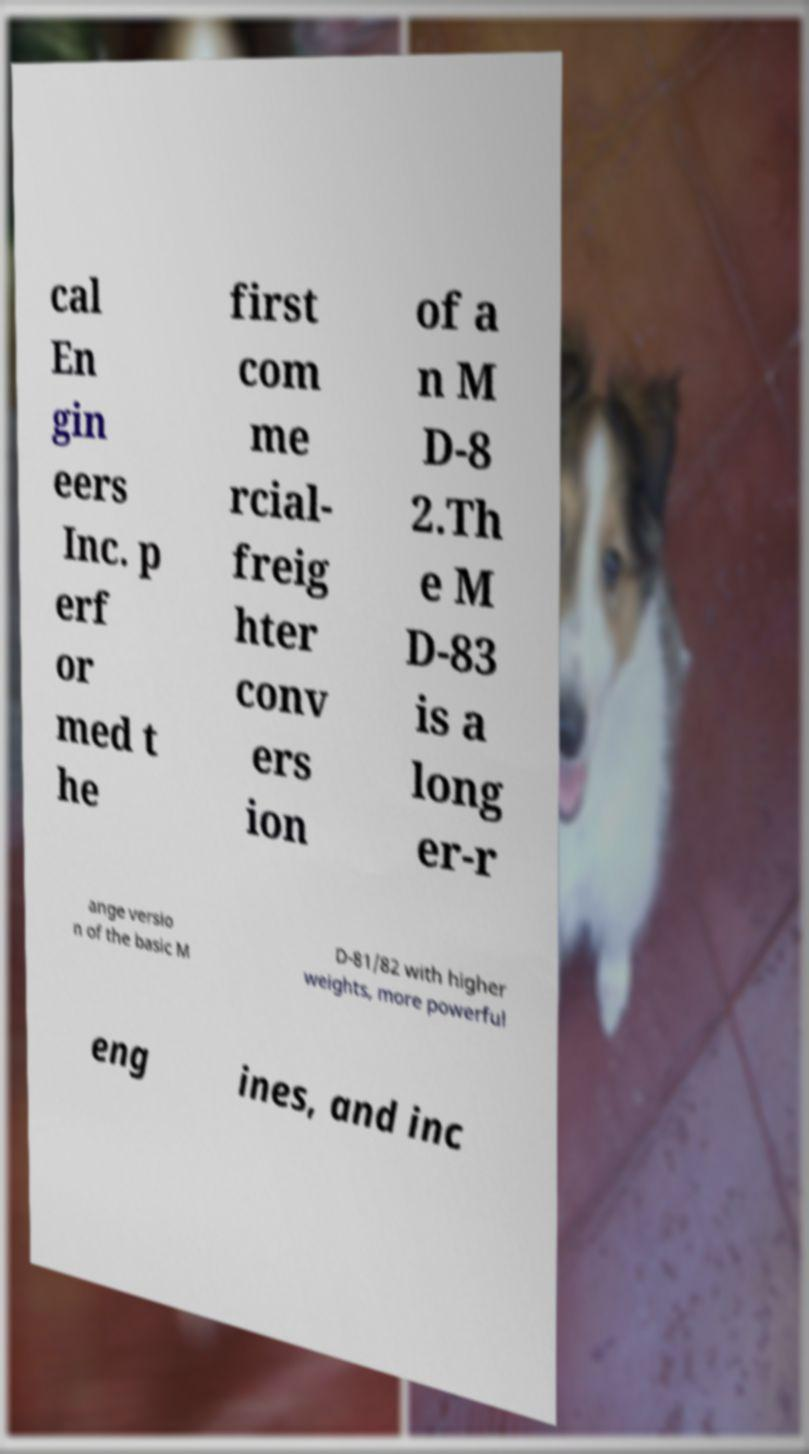Please identify and transcribe the text found in this image. cal En gin eers Inc. p erf or med t he first com me rcial- freig hter conv ers ion of a n M D-8 2.Th e M D-83 is a long er-r ange versio n of the basic M D-81/82 with higher weights, more powerful eng ines, and inc 